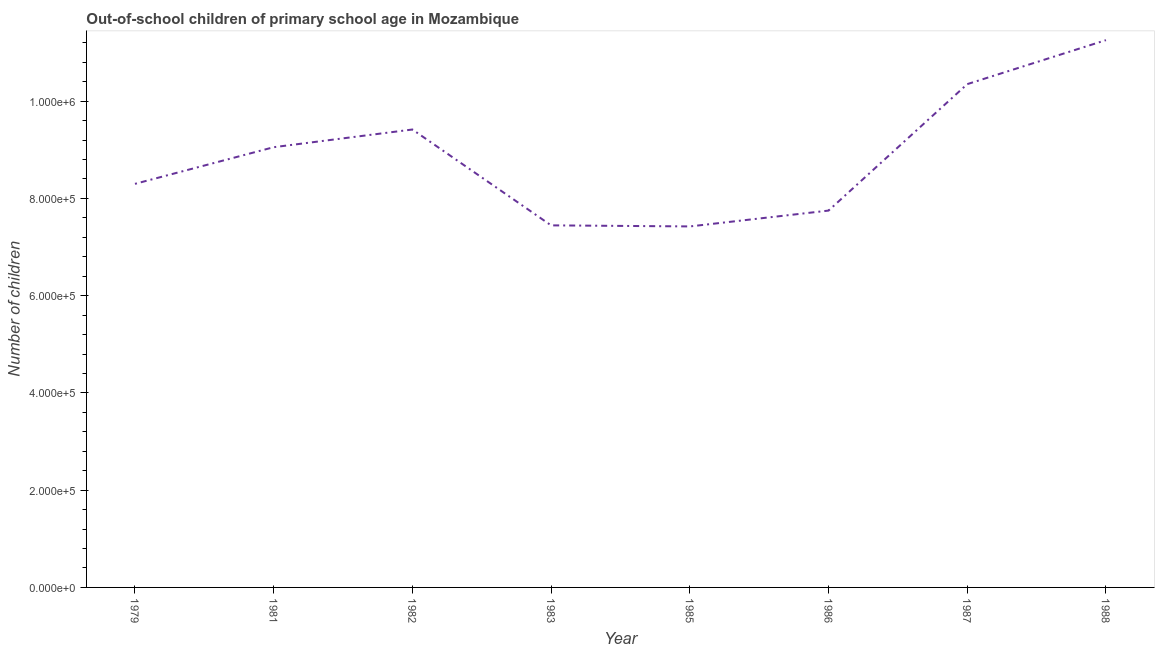What is the number of out-of-school children in 1987?
Provide a succinct answer. 1.03e+06. Across all years, what is the maximum number of out-of-school children?
Offer a very short reply. 1.13e+06. Across all years, what is the minimum number of out-of-school children?
Your answer should be very brief. 7.42e+05. In which year was the number of out-of-school children minimum?
Your response must be concise. 1985. What is the sum of the number of out-of-school children?
Offer a terse response. 7.10e+06. What is the difference between the number of out-of-school children in 1985 and 1988?
Keep it short and to the point. -3.83e+05. What is the average number of out-of-school children per year?
Your answer should be compact. 8.87e+05. What is the median number of out-of-school children?
Make the answer very short. 8.68e+05. In how many years, is the number of out-of-school children greater than 760000 ?
Provide a short and direct response. 6. Do a majority of the years between 1982 and 1986 (inclusive) have number of out-of-school children greater than 80000 ?
Ensure brevity in your answer.  Yes. What is the ratio of the number of out-of-school children in 1985 to that in 1986?
Offer a terse response. 0.96. Is the number of out-of-school children in 1985 less than that in 1986?
Provide a short and direct response. Yes. Is the difference between the number of out-of-school children in 1983 and 1988 greater than the difference between any two years?
Provide a short and direct response. No. What is the difference between the highest and the second highest number of out-of-school children?
Your answer should be compact. 9.05e+04. Is the sum of the number of out-of-school children in 1982 and 1986 greater than the maximum number of out-of-school children across all years?
Keep it short and to the point. Yes. What is the difference between the highest and the lowest number of out-of-school children?
Your response must be concise. 3.83e+05. Does the number of out-of-school children monotonically increase over the years?
Keep it short and to the point. No. How many lines are there?
Give a very brief answer. 1. How many years are there in the graph?
Offer a very short reply. 8. Does the graph contain any zero values?
Your answer should be very brief. No. Does the graph contain grids?
Make the answer very short. No. What is the title of the graph?
Ensure brevity in your answer.  Out-of-school children of primary school age in Mozambique. What is the label or title of the Y-axis?
Provide a succinct answer. Number of children. What is the Number of children of 1979?
Your answer should be compact. 8.30e+05. What is the Number of children in 1981?
Provide a short and direct response. 9.05e+05. What is the Number of children of 1982?
Make the answer very short. 9.42e+05. What is the Number of children in 1983?
Keep it short and to the point. 7.45e+05. What is the Number of children in 1985?
Keep it short and to the point. 7.42e+05. What is the Number of children in 1986?
Provide a succinct answer. 7.75e+05. What is the Number of children of 1987?
Provide a short and direct response. 1.03e+06. What is the Number of children of 1988?
Give a very brief answer. 1.13e+06. What is the difference between the Number of children in 1979 and 1981?
Provide a short and direct response. -7.54e+04. What is the difference between the Number of children in 1979 and 1982?
Provide a short and direct response. -1.12e+05. What is the difference between the Number of children in 1979 and 1983?
Make the answer very short. 8.54e+04. What is the difference between the Number of children in 1979 and 1985?
Offer a terse response. 8.76e+04. What is the difference between the Number of children in 1979 and 1986?
Provide a short and direct response. 5.50e+04. What is the difference between the Number of children in 1979 and 1987?
Provide a succinct answer. -2.05e+05. What is the difference between the Number of children in 1979 and 1988?
Keep it short and to the point. -2.96e+05. What is the difference between the Number of children in 1981 and 1982?
Make the answer very short. -3.64e+04. What is the difference between the Number of children in 1981 and 1983?
Your answer should be compact. 1.61e+05. What is the difference between the Number of children in 1981 and 1985?
Make the answer very short. 1.63e+05. What is the difference between the Number of children in 1981 and 1986?
Your response must be concise. 1.30e+05. What is the difference between the Number of children in 1981 and 1987?
Your answer should be very brief. -1.30e+05. What is the difference between the Number of children in 1981 and 1988?
Ensure brevity in your answer.  -2.20e+05. What is the difference between the Number of children in 1982 and 1983?
Provide a short and direct response. 1.97e+05. What is the difference between the Number of children in 1982 and 1985?
Your answer should be compact. 1.99e+05. What is the difference between the Number of children in 1982 and 1986?
Your answer should be compact. 1.67e+05. What is the difference between the Number of children in 1982 and 1987?
Keep it short and to the point. -9.33e+04. What is the difference between the Number of children in 1982 and 1988?
Your answer should be compact. -1.84e+05. What is the difference between the Number of children in 1983 and 1985?
Your response must be concise. 2186. What is the difference between the Number of children in 1983 and 1986?
Provide a succinct answer. -3.04e+04. What is the difference between the Number of children in 1983 and 1987?
Make the answer very short. -2.90e+05. What is the difference between the Number of children in 1983 and 1988?
Make the answer very short. -3.81e+05. What is the difference between the Number of children in 1985 and 1986?
Your answer should be very brief. -3.26e+04. What is the difference between the Number of children in 1985 and 1987?
Provide a short and direct response. -2.93e+05. What is the difference between the Number of children in 1985 and 1988?
Ensure brevity in your answer.  -3.83e+05. What is the difference between the Number of children in 1986 and 1987?
Keep it short and to the point. -2.60e+05. What is the difference between the Number of children in 1986 and 1988?
Offer a very short reply. -3.51e+05. What is the difference between the Number of children in 1987 and 1988?
Offer a terse response. -9.05e+04. What is the ratio of the Number of children in 1979 to that in 1981?
Your answer should be compact. 0.92. What is the ratio of the Number of children in 1979 to that in 1982?
Make the answer very short. 0.88. What is the ratio of the Number of children in 1979 to that in 1983?
Your response must be concise. 1.11. What is the ratio of the Number of children in 1979 to that in 1985?
Offer a terse response. 1.12. What is the ratio of the Number of children in 1979 to that in 1986?
Offer a terse response. 1.07. What is the ratio of the Number of children in 1979 to that in 1987?
Make the answer very short. 0.8. What is the ratio of the Number of children in 1979 to that in 1988?
Make the answer very short. 0.74. What is the ratio of the Number of children in 1981 to that in 1982?
Provide a succinct answer. 0.96. What is the ratio of the Number of children in 1981 to that in 1983?
Give a very brief answer. 1.22. What is the ratio of the Number of children in 1981 to that in 1985?
Your answer should be very brief. 1.22. What is the ratio of the Number of children in 1981 to that in 1986?
Offer a terse response. 1.17. What is the ratio of the Number of children in 1981 to that in 1988?
Offer a terse response. 0.8. What is the ratio of the Number of children in 1982 to that in 1983?
Your response must be concise. 1.26. What is the ratio of the Number of children in 1982 to that in 1985?
Offer a very short reply. 1.27. What is the ratio of the Number of children in 1982 to that in 1986?
Keep it short and to the point. 1.22. What is the ratio of the Number of children in 1982 to that in 1987?
Ensure brevity in your answer.  0.91. What is the ratio of the Number of children in 1982 to that in 1988?
Keep it short and to the point. 0.84. What is the ratio of the Number of children in 1983 to that in 1985?
Your answer should be compact. 1. What is the ratio of the Number of children in 1983 to that in 1987?
Offer a very short reply. 0.72. What is the ratio of the Number of children in 1983 to that in 1988?
Provide a short and direct response. 0.66. What is the ratio of the Number of children in 1985 to that in 1986?
Keep it short and to the point. 0.96. What is the ratio of the Number of children in 1985 to that in 1987?
Offer a terse response. 0.72. What is the ratio of the Number of children in 1985 to that in 1988?
Offer a terse response. 0.66. What is the ratio of the Number of children in 1986 to that in 1987?
Ensure brevity in your answer.  0.75. What is the ratio of the Number of children in 1986 to that in 1988?
Give a very brief answer. 0.69. What is the ratio of the Number of children in 1987 to that in 1988?
Provide a short and direct response. 0.92. 